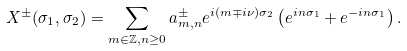<formula> <loc_0><loc_0><loc_500><loc_500>X ^ { \pm } ( \sigma _ { 1 } , \sigma _ { 2 } ) = \sum _ { m \in { \mathbb { Z } } , n \geq 0 } a ^ { \pm } _ { m , n } e ^ { i ( m \mp i \nu ) \sigma _ { 2 } } \left ( e ^ { i n \sigma _ { 1 } } + e ^ { - i n \sigma _ { 1 } } \right ) .</formula> 